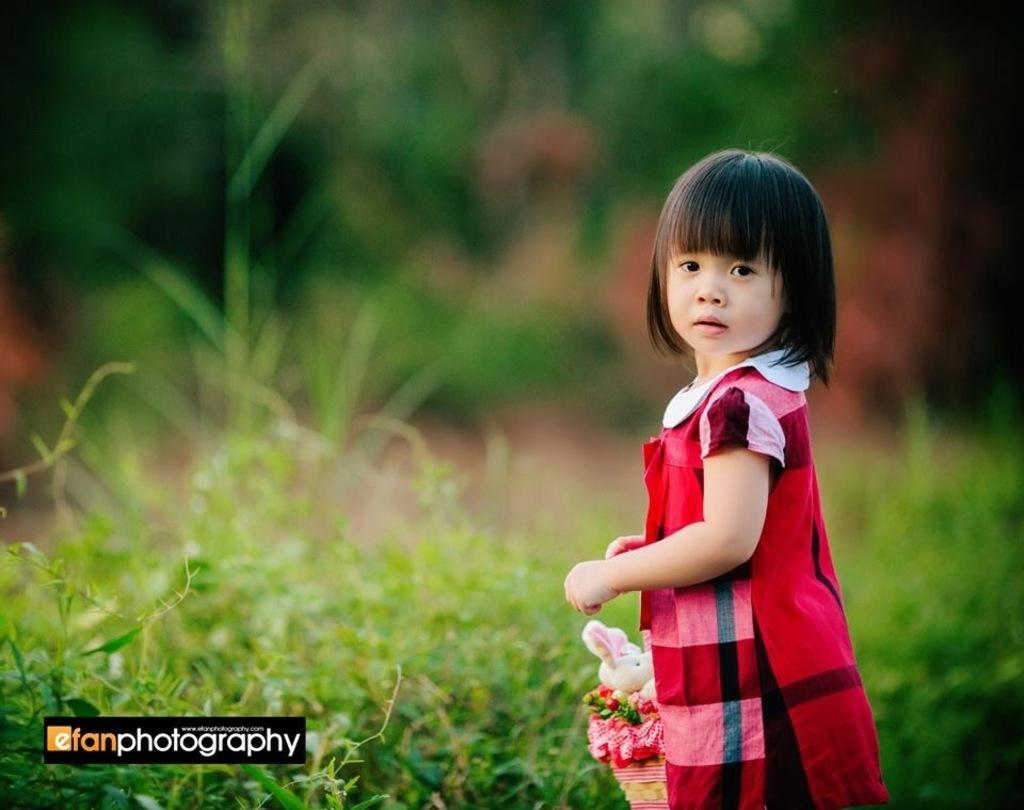Provide a one-sentence caption for the provided image. A girl on a green background copyrighted by efanphotography. 